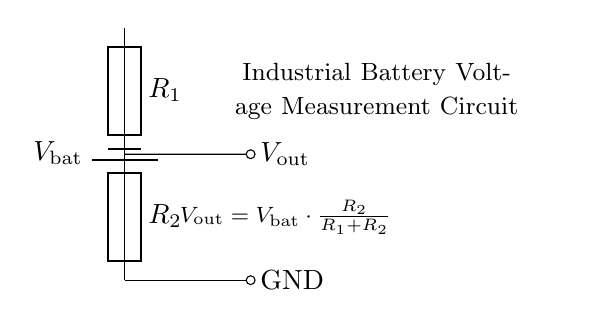What are the resistors in the circuit? The circuit contains two resistors labeled R1 and R2. These components are indicated directly in the circuit diagram.
Answer: R1, R2 What is the purpose of R1 and R2? R1 and R2 form a voltage divider. The function of this arrangement is to reduce the voltage from the battery to a lower level suitable for measurement.
Answer: Voltage divider What is the output voltage formula? The formula for the output voltage is depicted in the circuit: V out equals V bat multiplied by R2 divided by the sum of R1 and R2. This calculation uses the values of the resistors and the input voltage.
Answer: V out = V bat * (R2 / (R1 + R2)) What is V out in relation to V bat? V out is the reduced voltage that can be measured, resulting from the input voltage V bat across the two resistors. It is a fraction of the battery voltage determined by the resistor values.
Answer: Fraction of V bat How is V out measured? V out is measured across R2, as indicated by the short line pointing towards the output node in the circuit. This is where the output voltage is taken from the voltage divider setup.
Answer: Across R2 